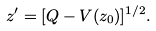Convert formula to latex. <formula><loc_0><loc_0><loc_500><loc_500>z ^ { \prime } = [ Q - V ( z _ { 0 } ) ] ^ { 1 / 2 } .</formula> 